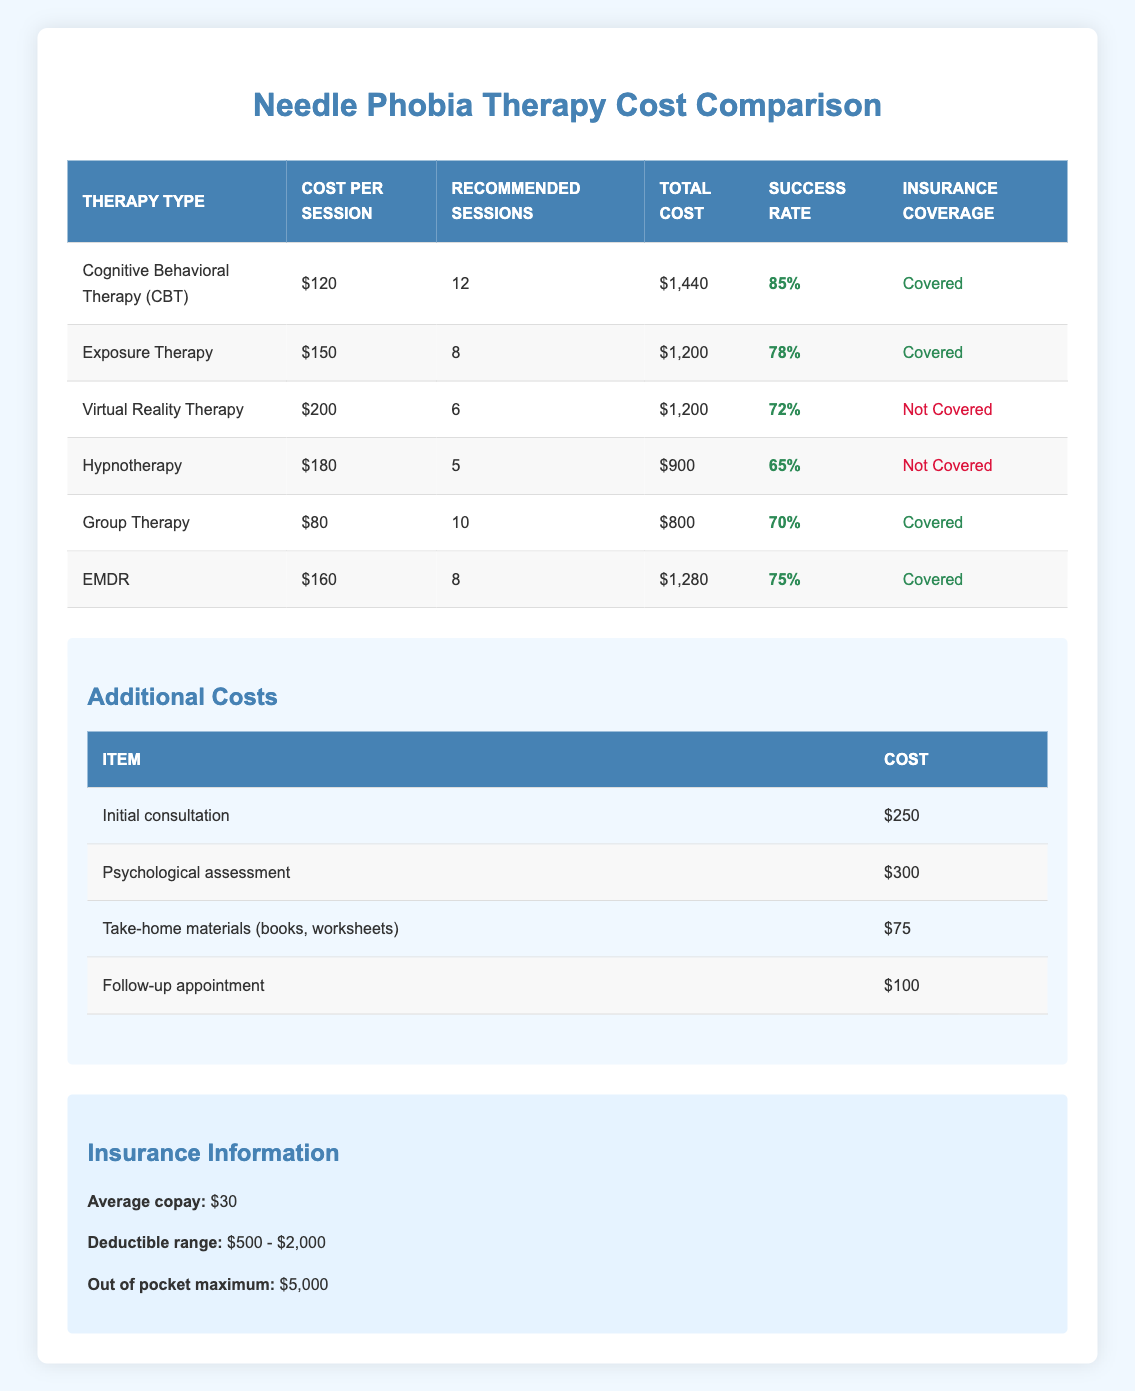What is the total cost for Cognitive Behavioral Therapy? The table shows that the total cost for Cognitive Behavioral Therapy (CBT) is specifically listed under the "Total Cost" column, which is $1,440.
Answer: $1,440 Which therapy has the highest success rate? The success rates are listed under the "Success Rate" column. Comparing all the success rates, Cognitive Behavioral Therapy (CBT) has the highest rate at 85%.
Answer: Cognitive Behavioral Therapy (CBT) Is Hypnotherapy covered by insurance? The table indicates whether each therapy option is covered by insurance under the "Insurance Coverage" column. Hypnotherapy is marked as "Not Covered."
Answer: No What is the average cost per session for Exposure Therapy? The average cost per session for Exposure Therapy is clearly stated in the table under the "Cost per Session" column, which is $150.
Answer: $150 If I choose Group Therapy, what would be the total cost, including the initial consultation and psychological assessment? The total cost for Group Therapy is listed as $800. Additionally, the initial consultation is $250 and the psychological assessment is $300. Thus, the total cost = $800 (Group Therapy) + $250 + $300 = $1,350.
Answer: $1,350 Which therapy option is the most cost-effective based on total cost? Evaluating the total costs listed in the table, Group Therapy is the most cost-effective at $800, the lowest total cost among all therapies.
Answer: Group Therapy How many sessions are recommended for Virtual Reality Therapy? The recommended sessions for Virtual Reality Therapy are directly given in the table under the "Recommended Sessions" column, which states 6 sessions.
Answer: 6 sessions What is the total additional cost for take-home materials and a follow-up appointment? The cost of take-home materials is $75 and the follow-up appointment is $100. Therefore, the total additional cost is $75 + $100 = $175.
Answer: $175 Are all therapy options covered by insurance? In the "Insurance Coverage" column, we can see that not all therapy options are covered. Specifically, Virtual Reality Therapy and Hypnotherapy are marked as "Not Covered."
Answer: No 